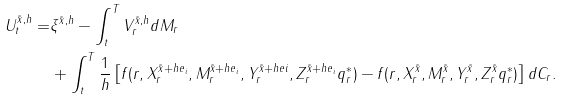<formula> <loc_0><loc_0><loc_500><loc_500>U _ { t } ^ { \tilde { x } , h } = & \xi ^ { \tilde { x } , h } - \int _ { t } ^ { T } V _ { r } ^ { \tilde { x } , h } d M _ { r } \\ & + \int _ { t } ^ { T } \frac { 1 } { h } \left [ f ( r , X _ { r } ^ { \tilde { x } + h e _ { i } } , M _ { r } ^ { \tilde { x } + h e _ { i } } , Y _ { r } ^ { \tilde { x } + h e i } , Z _ { r } ^ { \tilde { x } + h e _ { i } } q _ { r } ^ { \ast } ) - f ( r , X _ { r } ^ { \tilde { x } } , M _ { r } ^ { \tilde { x } } , Y _ { r } ^ { \tilde { x } } , Z _ { r } ^ { \tilde { x } } q _ { r } ^ { \ast } ) \right ] d C _ { r } .</formula> 